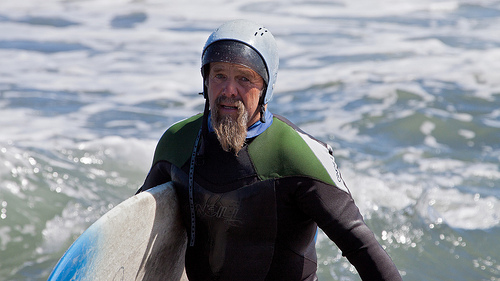Can you describe the surfer's attire and gear? The surfer is donning a two-tone wetsuit, predominantly black with green accents, and a white helmet. The choice of wetsuit suggests the water might be cool, requiring insulation for body warmth. 